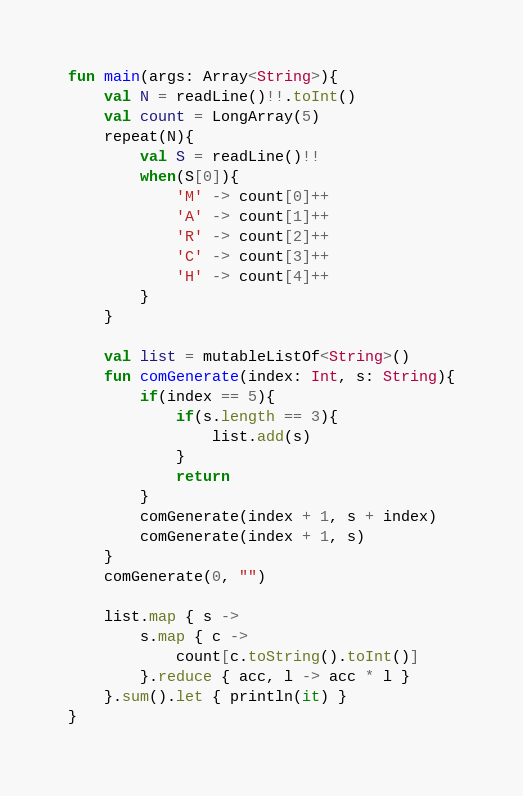Convert code to text. <code><loc_0><loc_0><loc_500><loc_500><_Kotlin_>fun main(args: Array<String>){
    val N = readLine()!!.toInt()
    val count = LongArray(5)
    repeat(N){
        val S = readLine()!!
        when(S[0]){
            'M' -> count[0]++
            'A' -> count[1]++
            'R' -> count[2]++
            'C' -> count[3]++
            'H' -> count[4]++
        }
    }

    val list = mutableListOf<String>()
    fun comGenerate(index: Int, s: String){
        if(index == 5){
            if(s.length == 3){
                list.add(s)
            }
            return
        }
        comGenerate(index + 1, s + index)
        comGenerate(index + 1, s)
    }
    comGenerate(0, "")

    list.map { s ->
        s.map { c ->
            count[c.toString().toInt()]
        }.reduce { acc, l -> acc * l }
    }.sum().let { println(it) }
}</code> 